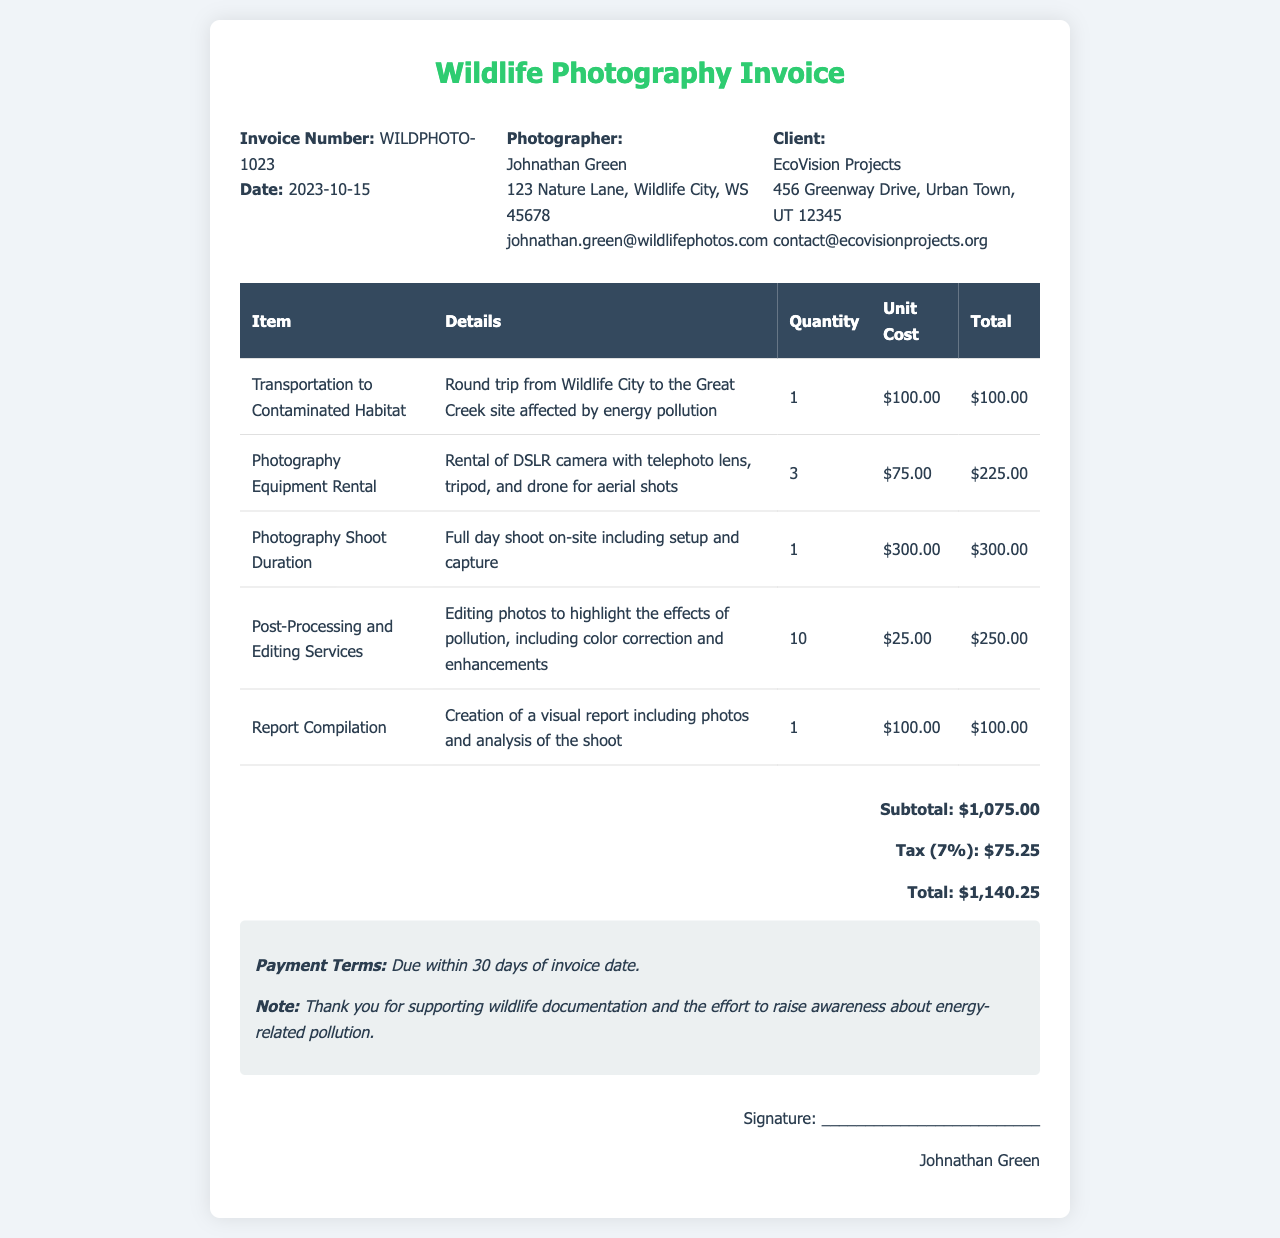What is the invoice number? The invoice number is clearly listed at the top of the document as a unique identifier.
Answer: WILDPHOTO-1023 What is the total amount due? The total amount due is presented at the bottom of the invoice, summarizing all costs including tax.
Answer: $1,140.25 Who is the photographer? The name of the photographer is mentioned in the invoice details section.
Answer: Johnathan Green What was the unit cost for photography equipment rental? The unit cost for photography equipment rental is specified in the invoice table.
Answer: $75.00 How many items were included in the invoice? The number of distinct items is determined by counting the entries in the invoice table.
Answer: 5 What is the date of the invoice? The date is clearly stated near the invoice number.
Answer: 2023-10-15 What percentage is the tax applied to the subtotal? The tax percentage is mentioned next to the tax calculation in the invoice.
Answer: 7% What is noted about the payment terms? The payment terms are specified in the notes section of the invoice.
Answer: Due within 30 days of invoice date What service was provided for post-processing? The details regarding post-processing are included in the description of one of the line items.
Answer: Editing photos to highlight the effects of pollution 